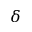<formula> <loc_0><loc_0><loc_500><loc_500>\delta</formula> 